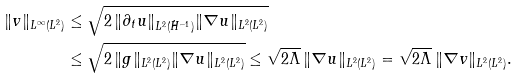<formula> <loc_0><loc_0><loc_500><loc_500>\| v \| _ { L ^ { \infty } ( L ^ { 2 } ) } & \leq \sqrt { 2 \, \| \partial _ { t } u \| _ { L ^ { 2 } ( \dot { H } ^ { - 1 } ) } \| \nabla u \| _ { L ^ { 2 } ( L ^ { 2 } ) } } \\ & \leq \sqrt { 2 \, \| g \| _ { L ^ { 2 } ( L ^ { 2 } ) } \| \nabla u \| _ { L ^ { 2 } ( L ^ { 2 } ) } } \leq \sqrt { 2 \Lambda } \, \| \nabla u \| _ { L ^ { 2 } ( L ^ { 2 } ) } = \sqrt { 2 \Lambda } \, \| \nabla v \| _ { L ^ { 2 } ( L ^ { 2 } ) } .</formula> 